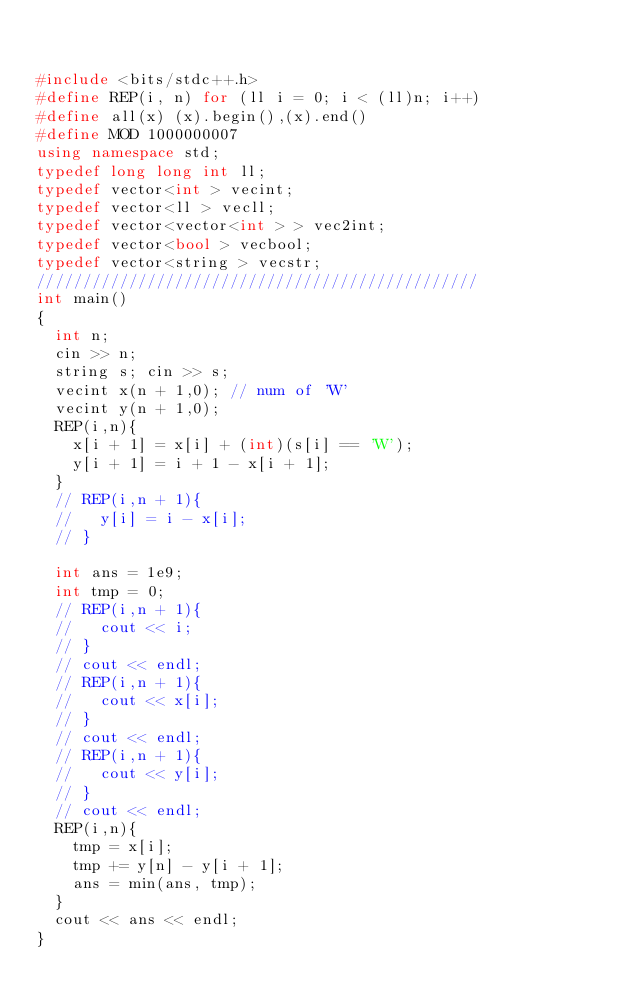Convert code to text. <code><loc_0><loc_0><loc_500><loc_500><_C++_>

#include <bits/stdc++.h>
#define REP(i, n) for (ll i = 0; i < (ll)n; i++)
#define all(x) (x).begin(),(x).end()
#define MOD 1000000007
using namespace std;
typedef long long int ll;
typedef vector<int > vecint;
typedef vector<ll > vecll;
typedef vector<vector<int > > vec2int;
typedef vector<bool > vecbool;
typedef vector<string > vecstr;
////////////////////////////////////////////////
int main()
{
  int n;
  cin >> n;
  string s; cin >> s;
  vecint x(n + 1,0); // num of 'W' 
  vecint y(n + 1,0);
  REP(i,n){
    x[i + 1] = x[i] + (int)(s[i] == 'W');
    y[i + 1] = i + 1 - x[i + 1];
  }
  // REP(i,n + 1){
  //   y[i] = i - x[i];
  // }

  int ans = 1e9;
  int tmp = 0;
  // REP(i,n + 1){
  //   cout << i;
  // }
  // cout << endl;
  // REP(i,n + 1){
  //   cout << x[i];
  // }
  // cout << endl;
  // REP(i,n + 1){
  //   cout << y[i];
  // }
  // cout << endl;
  REP(i,n){
    tmp = x[i];
    tmp += y[n] - y[i + 1];
    ans = min(ans, tmp);
  }
  cout << ans << endl;
}
</code> 